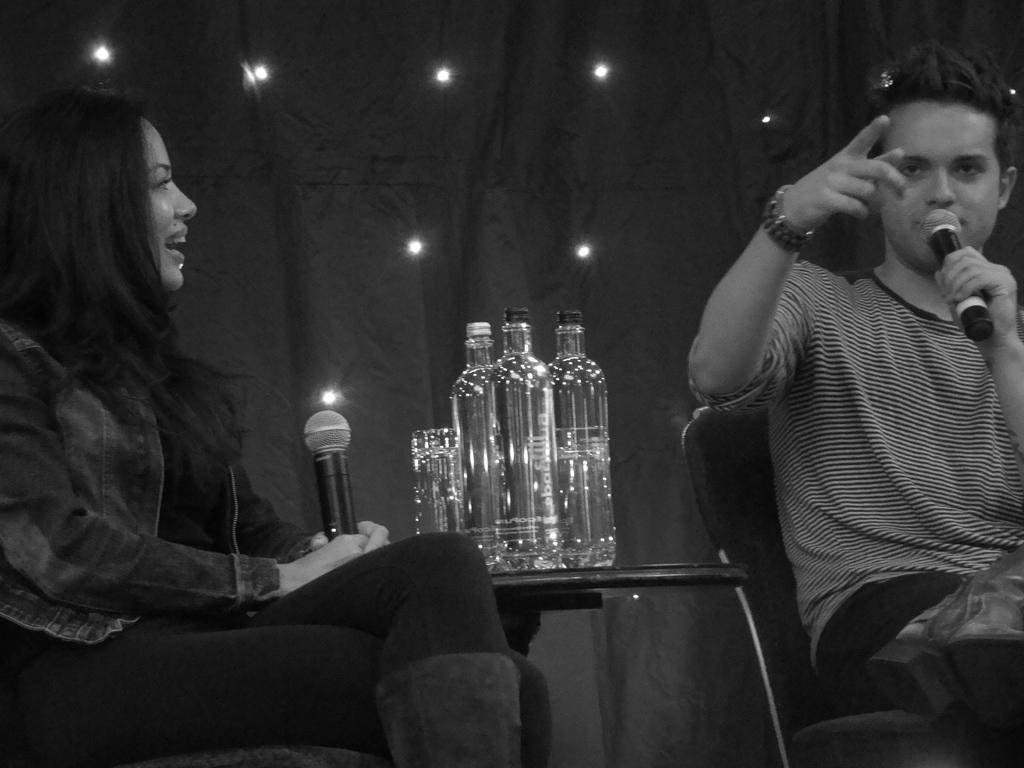Describe this image in one or two sentences. In this picture there are two persons. On the left side woman is holding mic and is having smile on her face. In the center there are bottles kept on the table. At the right side man is sitting on a chair and is holding mic and speaking. In the background there are lights and black colour curtain. 